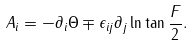Convert formula to latex. <formula><loc_0><loc_0><loc_500><loc_500>A _ { i } = - \partial _ { i } \Theta \mp \epsilon _ { i j } \partial _ { j } \ln \tan \frac { F } { 2 } .</formula> 